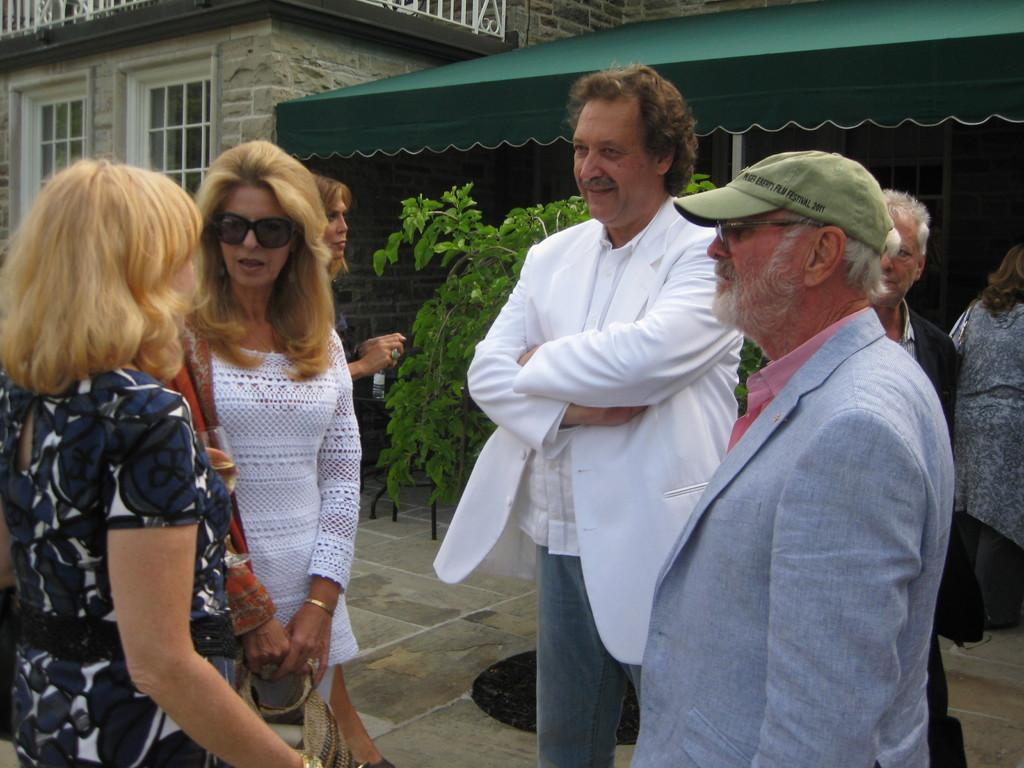How many people are visible in the front of the image? There are four persons standing in the image. Are there any other people visible in the image? Yes, there are other persons behind them. What can be seen in the background of the image? There is a plant and a building in the background of the image. What type of beef is being cooked on the stove in the image? There is no stove or beef present in the image. What angle is the image taken from? The angle from which the image is taken cannot be determined from the image itself. 